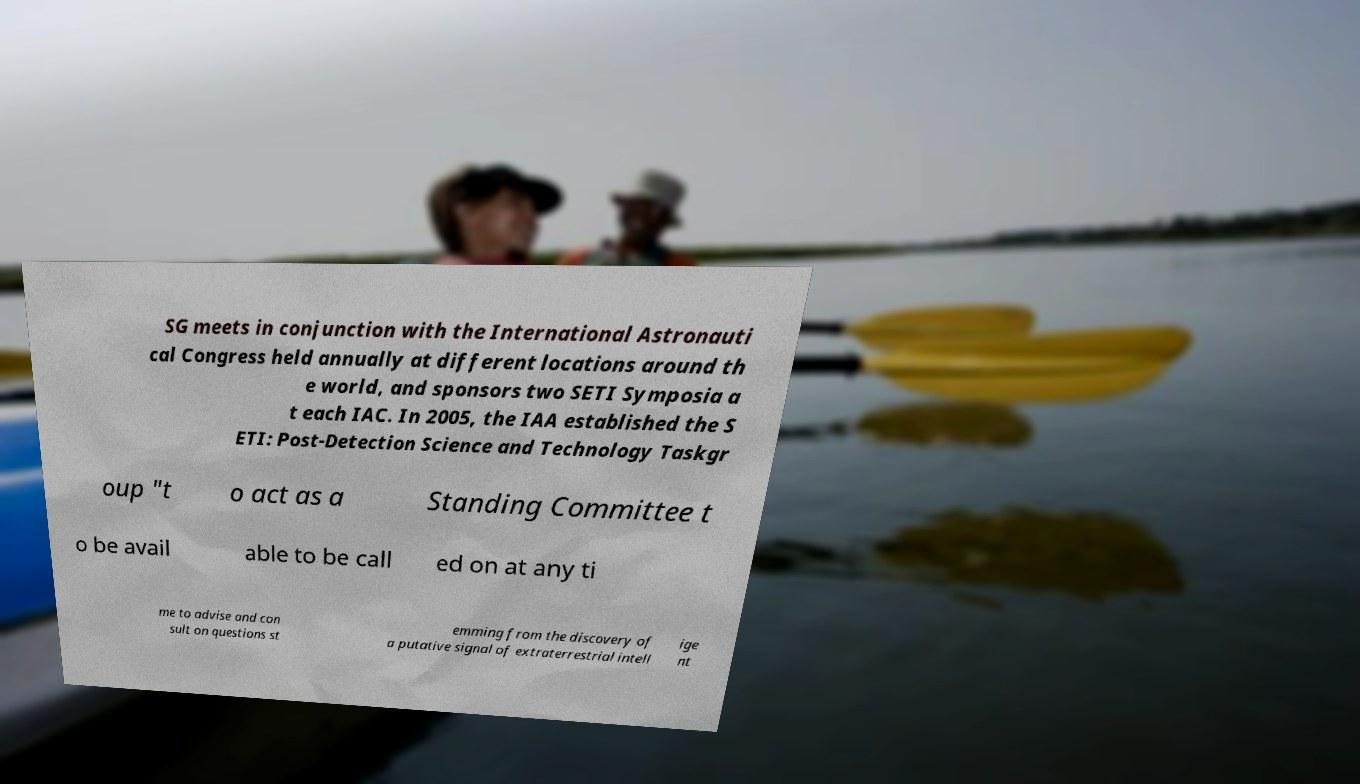Please read and relay the text visible in this image. What does it say? SG meets in conjunction with the International Astronauti cal Congress held annually at different locations around th e world, and sponsors two SETI Symposia a t each IAC. In 2005, the IAA established the S ETI: Post-Detection Science and Technology Taskgr oup "t o act as a Standing Committee t o be avail able to be call ed on at any ti me to advise and con sult on questions st emming from the discovery of a putative signal of extraterrestrial intell ige nt 